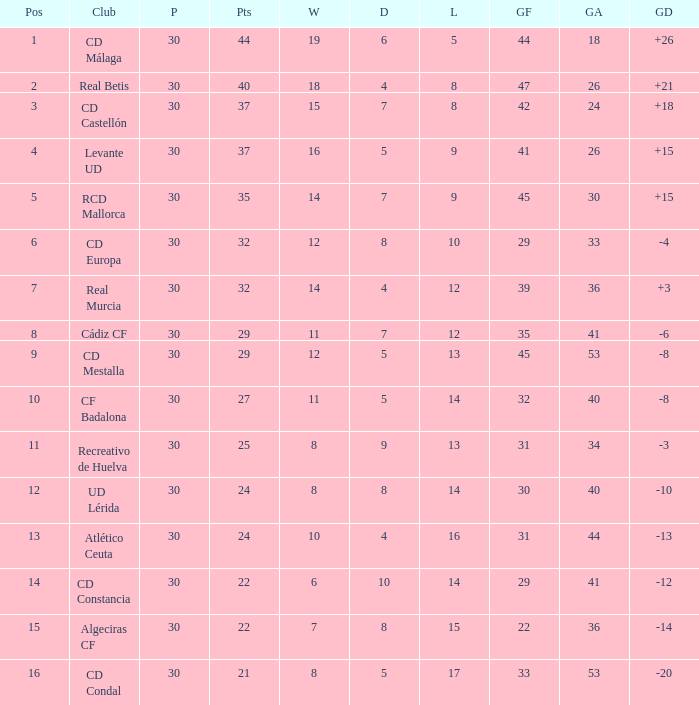What is the goals for when played is larger than 30? None. 